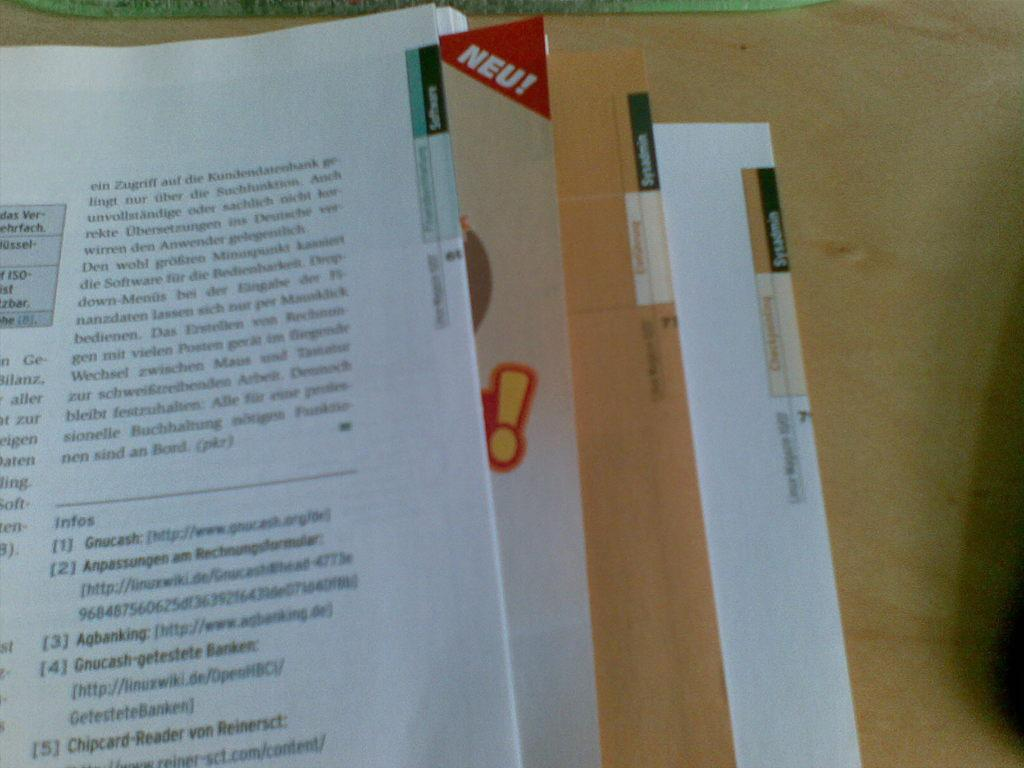<image>
Describe the image concisely. a  book is open and has a bookmark that has the word Neu! on it 